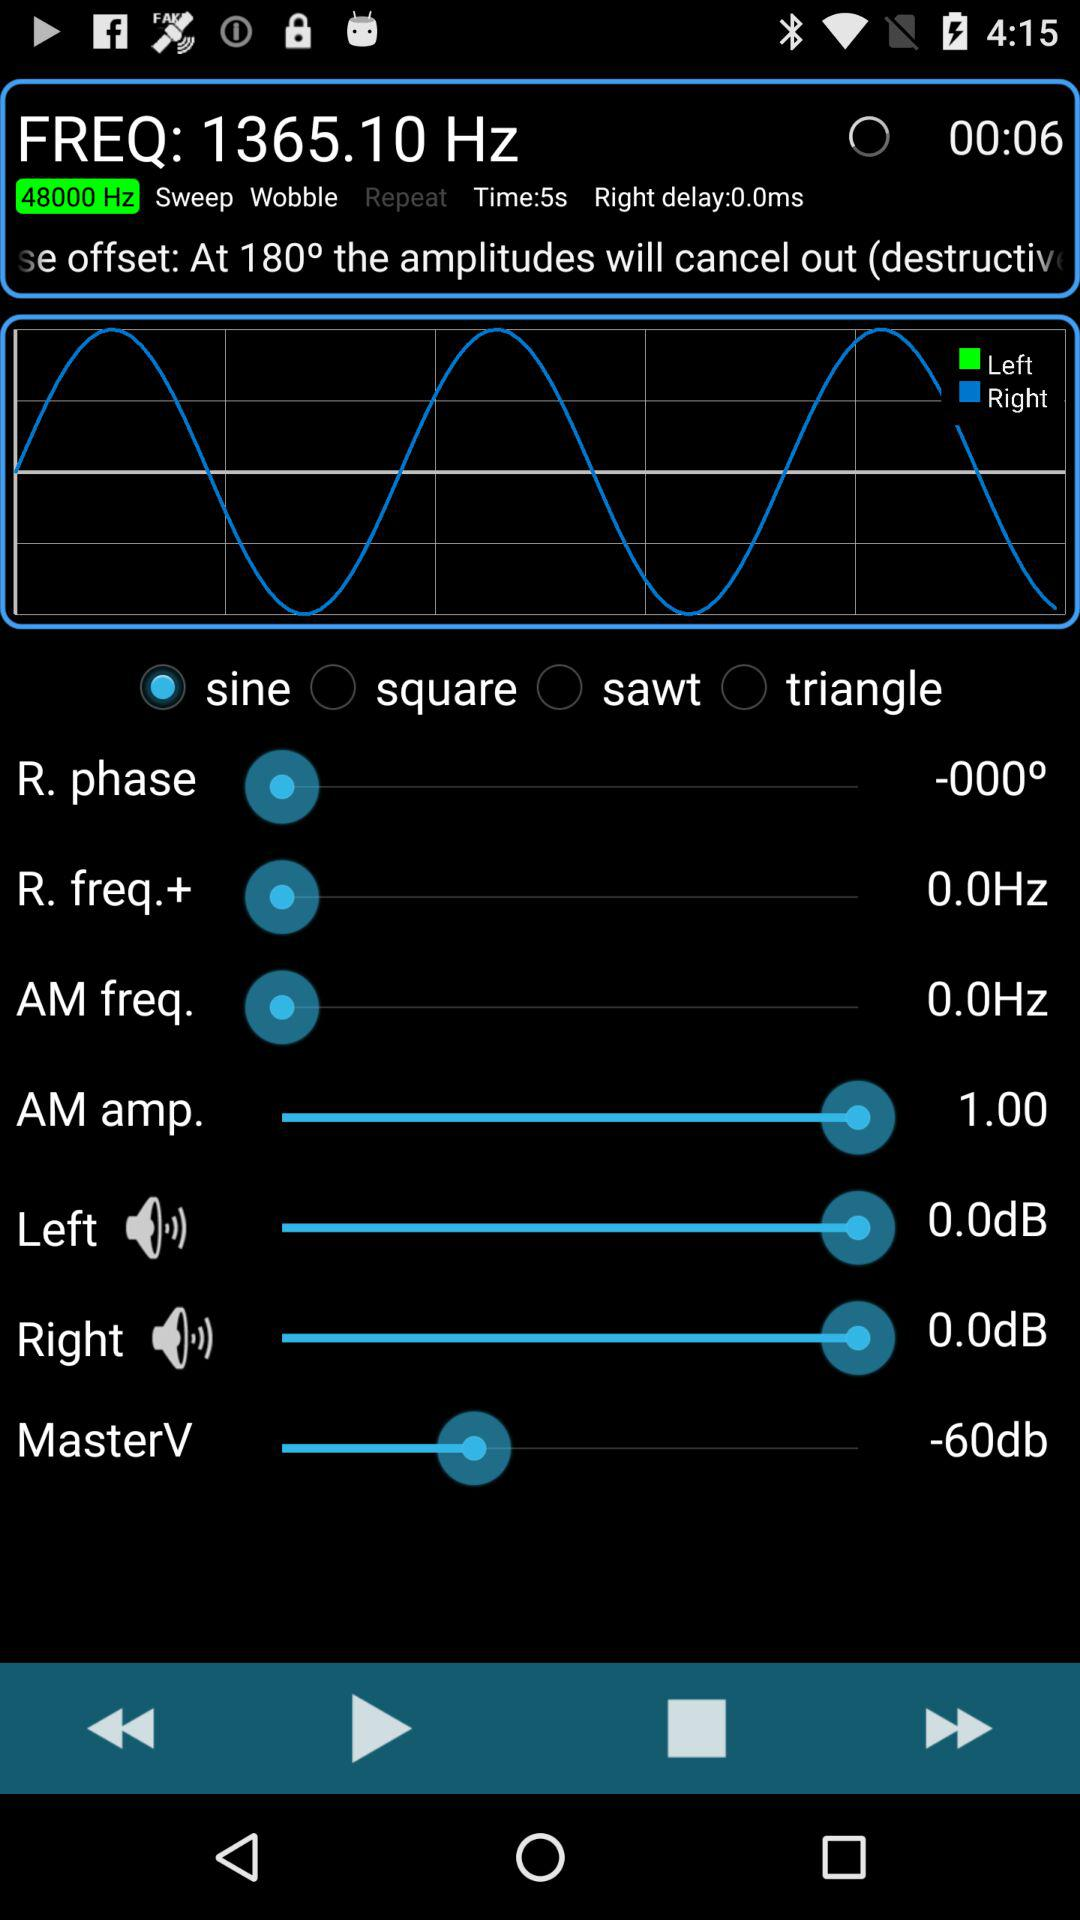What is the angle of the "R. phase" in degrees? The angle of the "R. phase" in degrees is 0. 